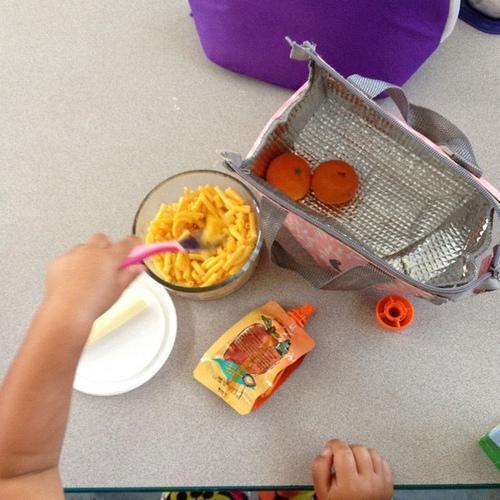How many oranges are there?
Give a very brief answer. 2. 